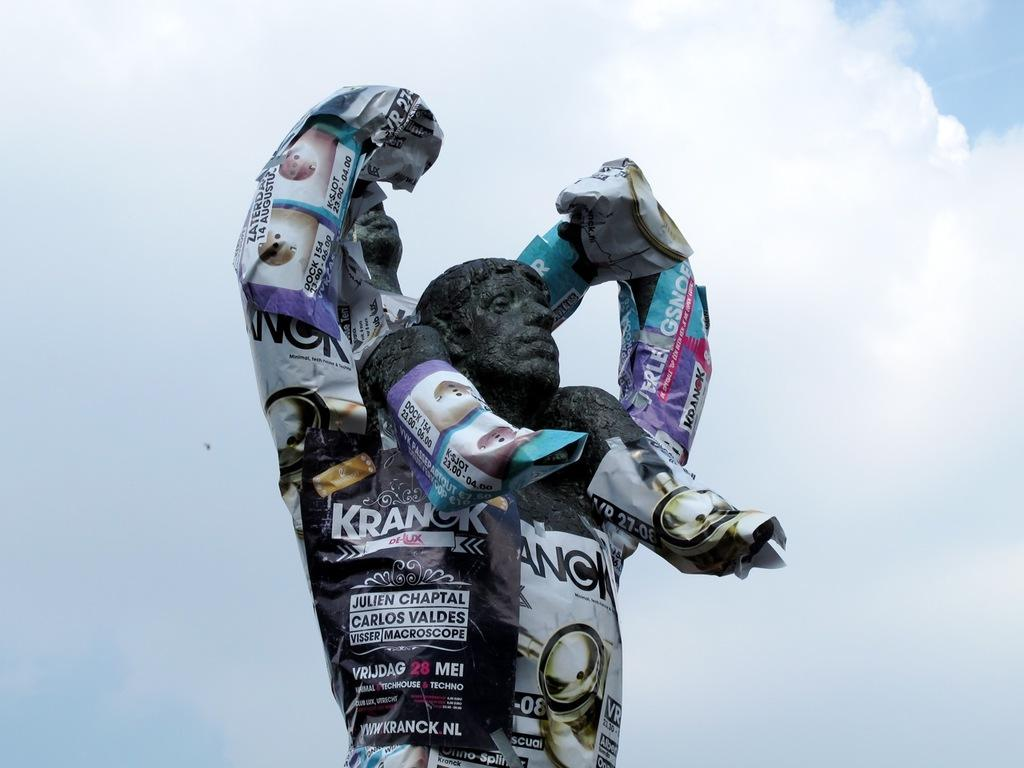What is the main subject of the image? There is a statue of a man in the image. What is on the statue? The statue has papers on it. What can be seen in the background of the image? The sky is visible in the image. What is the condition of the sky in the image? There are clouds in the sky. What type of cord is wrapped around the statue in the image? There is no cord wrapped around the statue in the image; it only has papers on it. 